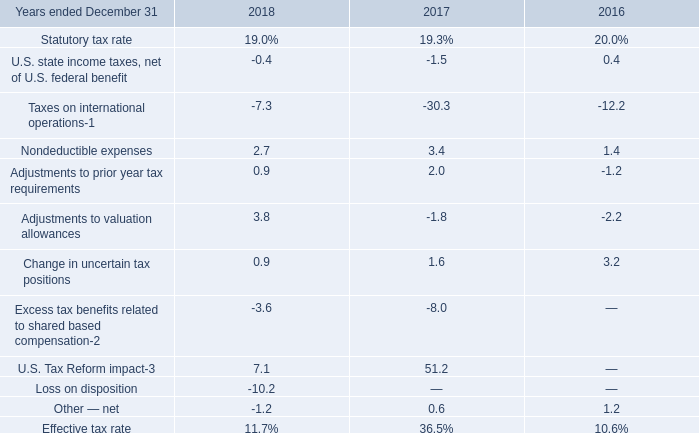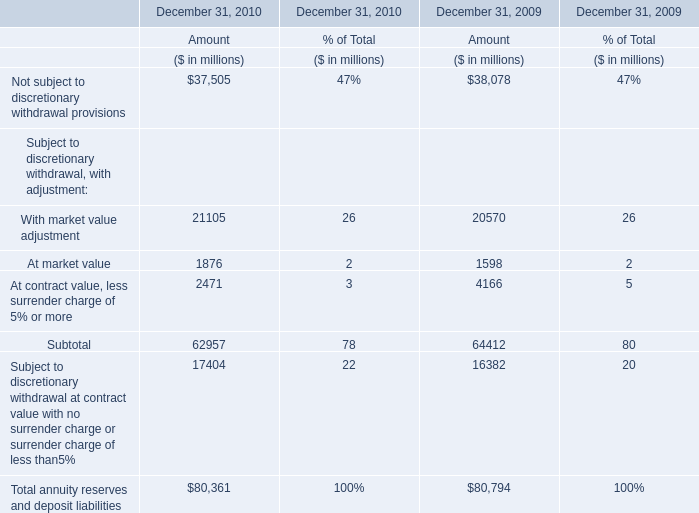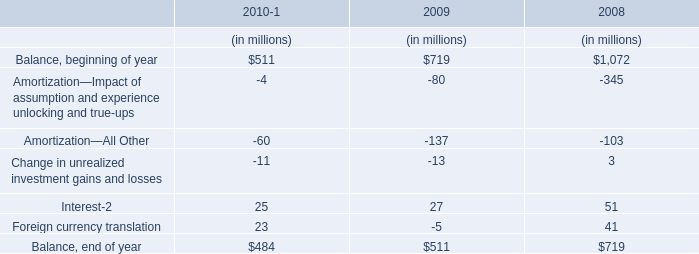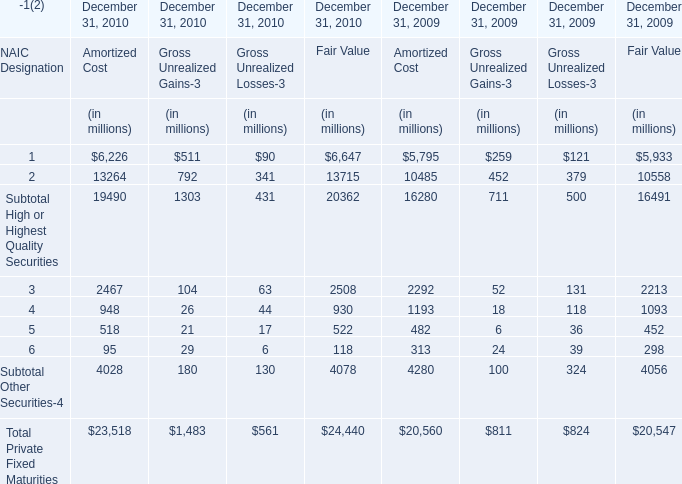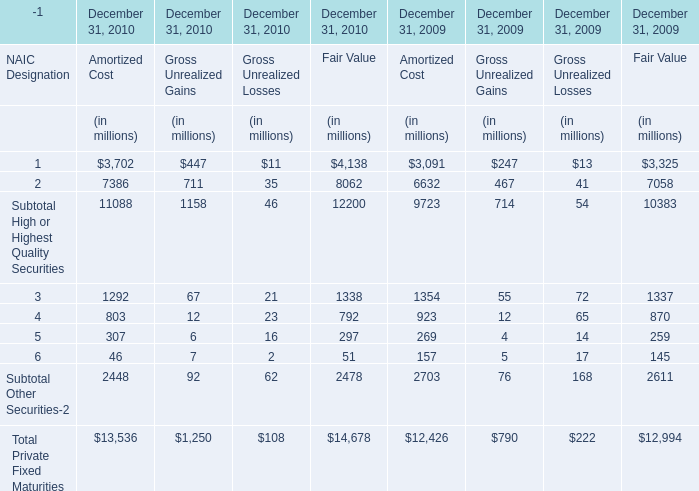If Subtotal Other Securities-2 in fair value develops with the same growth rate in 2010, what will it reach in 2011? (in million) 
Computations: ((((2478 - 2611) / 2611) + 1) * 2478)
Answer: 2351.7748. 